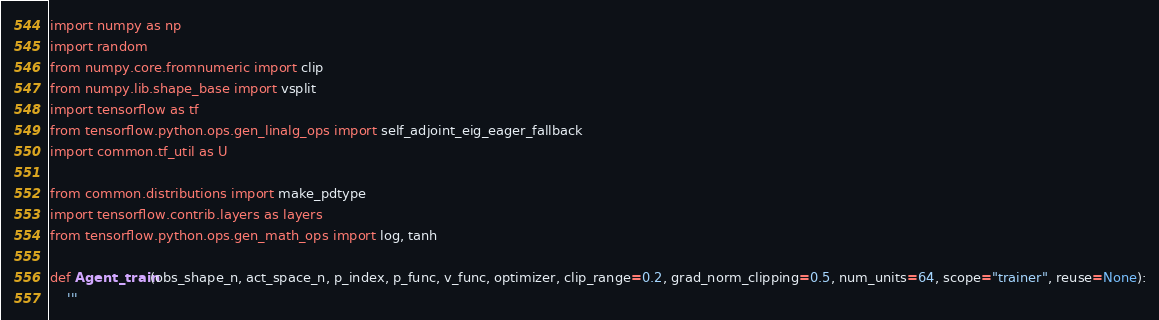Convert code to text. <code><loc_0><loc_0><loc_500><loc_500><_Python_>import numpy as np
import random
from numpy.core.fromnumeric import clip
from numpy.lib.shape_base import vsplit
import tensorflow as tf
from tensorflow.python.ops.gen_linalg_ops import self_adjoint_eig_eager_fallback
import common.tf_util as U

from common.distributions import make_pdtype
import tensorflow.contrib.layers as layers
from tensorflow.python.ops.gen_math_ops import log, tanh

def Agent_train(obs_shape_n, act_space_n, p_index, p_func, v_func, optimizer, clip_range=0.2, grad_norm_clipping=0.5, num_units=64, scope="trainer", reuse=None):
    '''</code> 